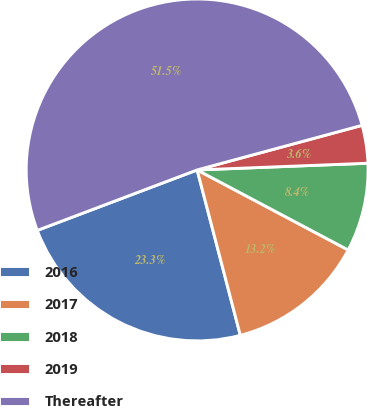Convert chart to OTSL. <chart><loc_0><loc_0><loc_500><loc_500><pie_chart><fcel>2016<fcel>2017<fcel>2018<fcel>2019<fcel>Thereafter<nl><fcel>23.31%<fcel>13.18%<fcel>8.38%<fcel>3.58%<fcel>51.55%<nl></chart> 